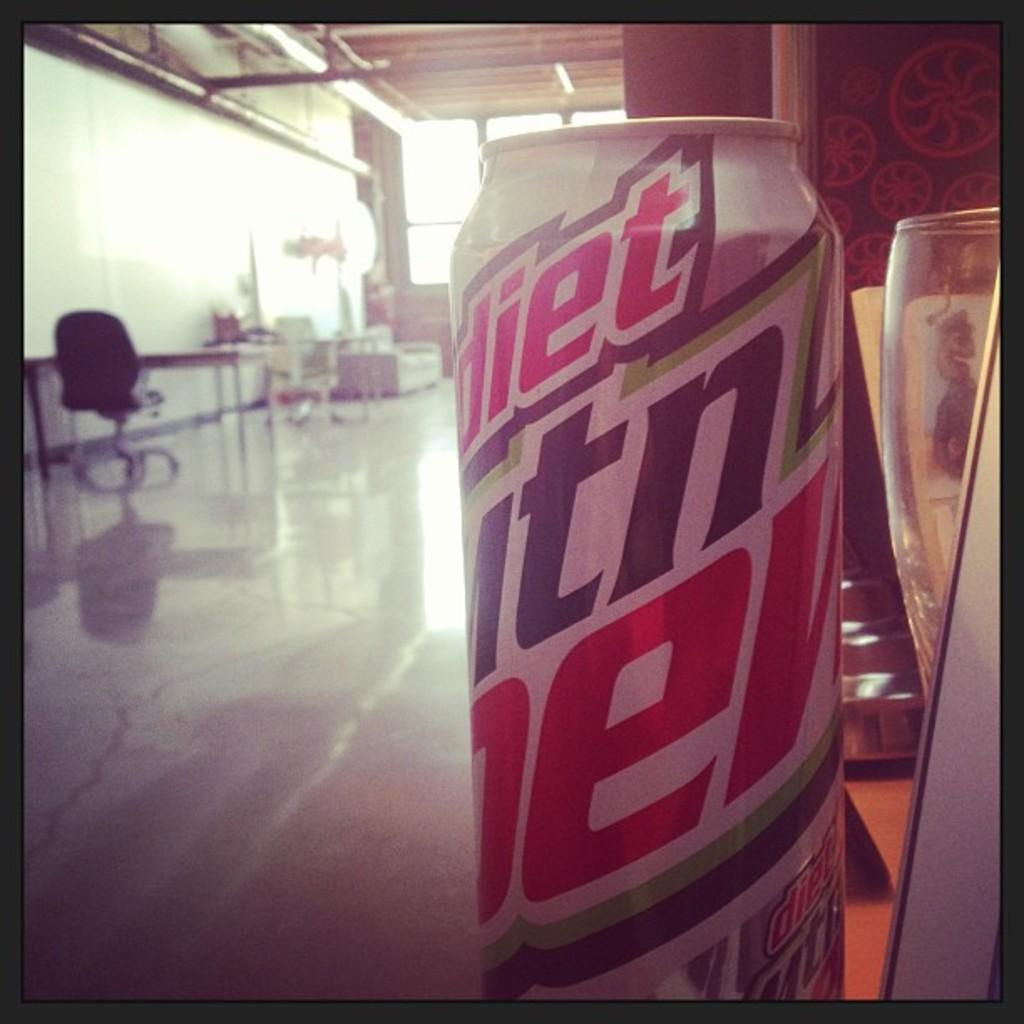Provide a one-sentence caption for the provided image. A Diet Man Dew soda can sitting on the edge of a table or bar with a glass to the right of it. 